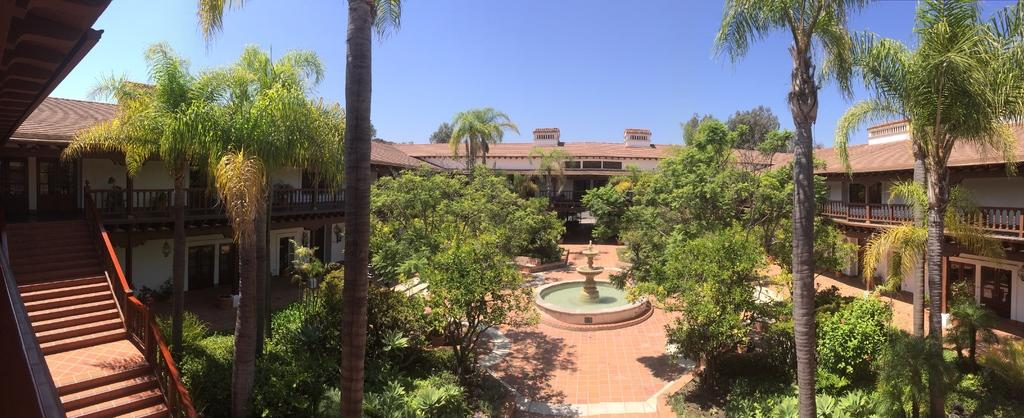What is located on the ground in the image? There is a fountain on the ground in the image. What architectural feature can be seen in the image? There is a staircase in the image. What type of structures are present in the image? There are buildings in the image. What type of vegetation is present in the image? There are trees in the image. What type of barrier is present in the image? There is a fence in the image. What type of plants are present in the image? There are house plants in the image. What is visible in the background of the image? The sky is visible in the background of the image. Can you tell me how many baby jeans are hanging on the fence in the image? There are no baby jeans present in the image; the image features a fountain, staircase, buildings, trees, a fence, house plants, and a visible sky. Are there any ants crawling on the house plants in the image? There is no mention of ants in the image; it only features a fountain, staircase, buildings, trees, a fence, house plants, and a visible sky. 